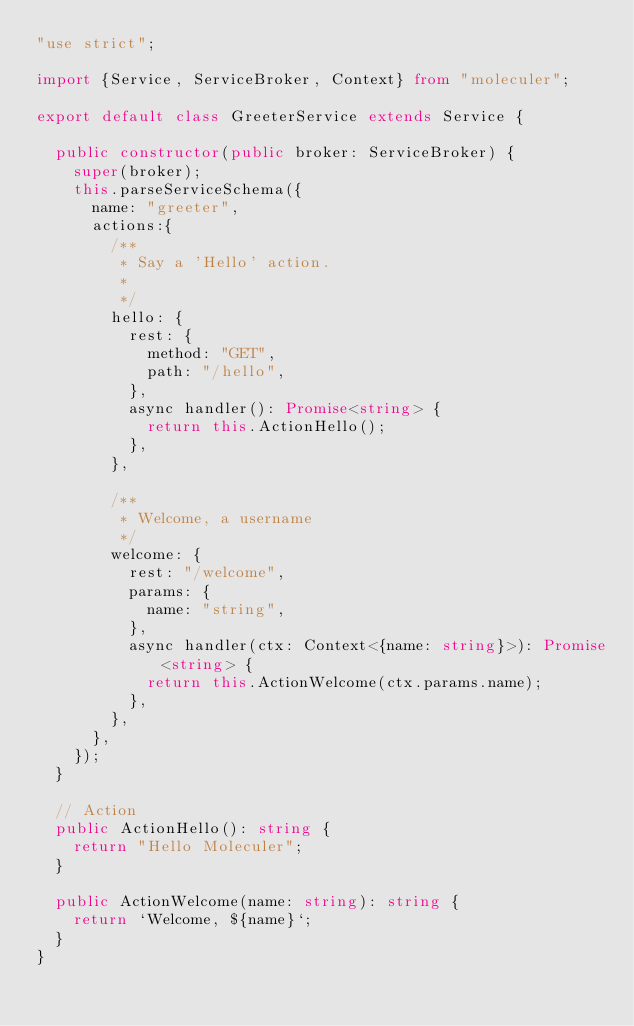<code> <loc_0><loc_0><loc_500><loc_500><_TypeScript_>"use strict";

import {Service, ServiceBroker, Context} from "moleculer";

export default class GreeterService extends Service {

	public constructor(public broker: ServiceBroker) {
		super(broker);
		this.parseServiceSchema({
			name: "greeter",
			actions:{
				/**
				 * Say a 'Hello' action.
				 *
				 */
				hello: {
					rest: {
						method: "GET",
						path: "/hello",
					},
					async handler(): Promise<string> {
						return this.ActionHello();
					},
				},

				/**
				 * Welcome, a username
				 */
				welcome: {
					rest: "/welcome",
					params: {
						name: "string",
					},
					async handler(ctx: Context<{name: string}>): Promise<string> {
						return this.ActionWelcome(ctx.params.name);
					},
				},
			},
		});
	}

	// Action
	public ActionHello(): string {
		return "Hello Moleculer";
	}

	public ActionWelcome(name: string): string {
		return `Welcome, ${name}`;
	}
}
</code> 